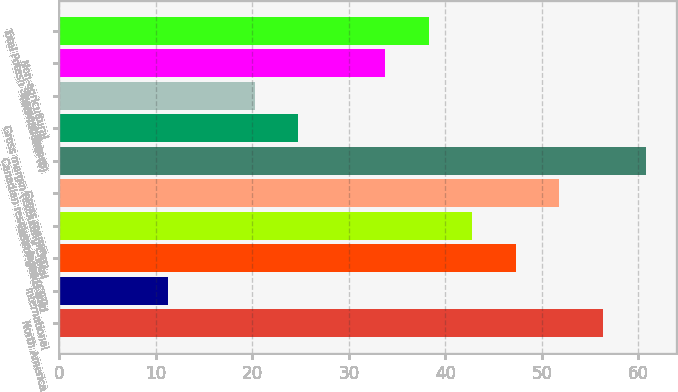<chart> <loc_0><loc_0><loc_500><loc_500><bar_chart><fcel>North America<fcel>International<fcel>Total<fcel>Cost of goods sold<fcel>Gross margin<fcel>Canadian resource taxes (CRT)<fcel>Gross margin (excluding CRT)<fcel>International (b)<fcel>Non-agricultural<fcel>Total Potash Segment Tonnes<nl><fcel>56.32<fcel>11.22<fcel>47.3<fcel>42.79<fcel>51.81<fcel>60.83<fcel>24.75<fcel>20.24<fcel>33.77<fcel>38.28<nl></chart> 